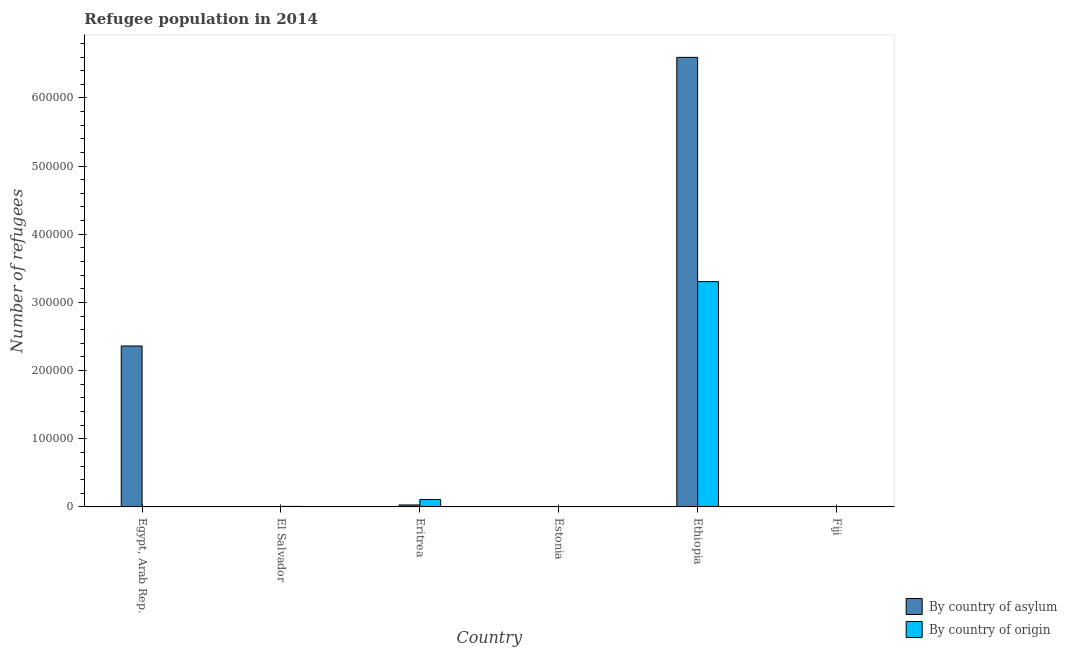How many groups of bars are there?
Your answer should be very brief. 6. Are the number of bars per tick equal to the number of legend labels?
Your answer should be very brief. Yes. Are the number of bars on each tick of the X-axis equal?
Provide a succinct answer. Yes. What is the label of the 3rd group of bars from the left?
Make the answer very short. Eritrea. In how many cases, is the number of bars for a given country not equal to the number of legend labels?
Offer a very short reply. 0. What is the number of refugees by country of origin in Fiji?
Make the answer very short. 339. Across all countries, what is the maximum number of refugees by country of origin?
Your answer should be very brief. 3.31e+05. Across all countries, what is the minimum number of refugees by country of asylum?
Make the answer very short. 13. In which country was the number of refugees by country of origin maximum?
Make the answer very short. Ethiopia. In which country was the number of refugees by country of origin minimum?
Provide a succinct answer. Estonia. What is the total number of refugees by country of asylum in the graph?
Provide a succinct answer. 8.99e+05. What is the difference between the number of refugees by country of asylum in Egypt, Arab Rep. and that in Fiji?
Make the answer very short. 2.36e+05. What is the difference between the number of refugees by country of origin in Fiji and the number of refugees by country of asylum in Estonia?
Provide a succinct answer. 249. What is the average number of refugees by country of asylum per country?
Your response must be concise. 1.50e+05. What is the difference between the number of refugees by country of asylum and number of refugees by country of origin in El Salvador?
Your response must be concise. -770. In how many countries, is the number of refugees by country of asylum greater than 660000 ?
Give a very brief answer. 0. What is the ratio of the number of refugees by country of origin in Egypt, Arab Rep. to that in Eritrea?
Offer a terse response. 0.03. What is the difference between the highest and the second highest number of refugees by country of origin?
Provide a succinct answer. 3.20e+05. What is the difference between the highest and the lowest number of refugees by country of asylum?
Make the answer very short. 6.60e+05. Is the sum of the number of refugees by country of asylum in Ethiopia and Fiji greater than the maximum number of refugees by country of origin across all countries?
Your answer should be very brief. Yes. What does the 1st bar from the left in Fiji represents?
Ensure brevity in your answer.  By country of asylum. What does the 1st bar from the right in El Salvador represents?
Give a very brief answer. By country of origin. How many bars are there?
Provide a succinct answer. 12. Are all the bars in the graph horizontal?
Keep it short and to the point. No. How many countries are there in the graph?
Make the answer very short. 6. Are the values on the major ticks of Y-axis written in scientific E-notation?
Offer a terse response. No. Does the graph contain grids?
Provide a short and direct response. No. How many legend labels are there?
Make the answer very short. 2. How are the legend labels stacked?
Give a very brief answer. Vertical. What is the title of the graph?
Offer a terse response. Refugee population in 2014. What is the label or title of the X-axis?
Offer a very short reply. Country. What is the label or title of the Y-axis?
Your answer should be compact. Number of refugees. What is the Number of refugees of By country of asylum in Egypt, Arab Rep.?
Keep it short and to the point. 2.36e+05. What is the Number of refugees of By country of origin in Egypt, Arab Rep.?
Your answer should be compact. 349. What is the Number of refugees in By country of asylum in El Salvador?
Your response must be concise. 35. What is the Number of refugees in By country of origin in El Salvador?
Make the answer very short. 805. What is the Number of refugees of By country of asylum in Eritrea?
Offer a very short reply. 2898. What is the Number of refugees of By country of origin in Eritrea?
Provide a short and direct response. 1.10e+04. What is the Number of refugees in By country of origin in Estonia?
Provide a succinct answer. 174. What is the Number of refugees of By country of asylum in Ethiopia?
Ensure brevity in your answer.  6.60e+05. What is the Number of refugees of By country of origin in Ethiopia?
Your answer should be very brief. 3.31e+05. What is the Number of refugees of By country of asylum in Fiji?
Offer a terse response. 13. What is the Number of refugees of By country of origin in Fiji?
Keep it short and to the point. 339. Across all countries, what is the maximum Number of refugees of By country of asylum?
Your response must be concise. 6.60e+05. Across all countries, what is the maximum Number of refugees in By country of origin?
Your answer should be compact. 3.31e+05. Across all countries, what is the minimum Number of refugees of By country of asylum?
Make the answer very short. 13. Across all countries, what is the minimum Number of refugees of By country of origin?
Give a very brief answer. 174. What is the total Number of refugees of By country of asylum in the graph?
Provide a succinct answer. 8.99e+05. What is the total Number of refugees of By country of origin in the graph?
Your answer should be very brief. 3.43e+05. What is the difference between the Number of refugees in By country of asylum in Egypt, Arab Rep. and that in El Salvador?
Your answer should be compact. 2.36e+05. What is the difference between the Number of refugees in By country of origin in Egypt, Arab Rep. and that in El Salvador?
Keep it short and to the point. -456. What is the difference between the Number of refugees in By country of asylum in Egypt, Arab Rep. and that in Eritrea?
Make the answer very short. 2.33e+05. What is the difference between the Number of refugees in By country of origin in Egypt, Arab Rep. and that in Eritrea?
Offer a very short reply. -1.06e+04. What is the difference between the Number of refugees in By country of asylum in Egypt, Arab Rep. and that in Estonia?
Your response must be concise. 2.36e+05. What is the difference between the Number of refugees of By country of origin in Egypt, Arab Rep. and that in Estonia?
Keep it short and to the point. 175. What is the difference between the Number of refugees of By country of asylum in Egypt, Arab Rep. and that in Ethiopia?
Offer a very short reply. -4.23e+05. What is the difference between the Number of refugees in By country of origin in Egypt, Arab Rep. and that in Ethiopia?
Your answer should be very brief. -3.30e+05. What is the difference between the Number of refugees in By country of asylum in Egypt, Arab Rep. and that in Fiji?
Ensure brevity in your answer.  2.36e+05. What is the difference between the Number of refugees in By country of origin in Egypt, Arab Rep. and that in Fiji?
Keep it short and to the point. 10. What is the difference between the Number of refugees in By country of asylum in El Salvador and that in Eritrea?
Your answer should be very brief. -2863. What is the difference between the Number of refugees of By country of origin in El Salvador and that in Eritrea?
Ensure brevity in your answer.  -1.02e+04. What is the difference between the Number of refugees in By country of asylum in El Salvador and that in Estonia?
Keep it short and to the point. -55. What is the difference between the Number of refugees in By country of origin in El Salvador and that in Estonia?
Offer a very short reply. 631. What is the difference between the Number of refugees of By country of asylum in El Salvador and that in Ethiopia?
Provide a succinct answer. -6.59e+05. What is the difference between the Number of refugees of By country of origin in El Salvador and that in Ethiopia?
Your answer should be very brief. -3.30e+05. What is the difference between the Number of refugees of By country of origin in El Salvador and that in Fiji?
Your answer should be compact. 466. What is the difference between the Number of refugees of By country of asylum in Eritrea and that in Estonia?
Your answer should be very brief. 2808. What is the difference between the Number of refugees in By country of origin in Eritrea and that in Estonia?
Ensure brevity in your answer.  1.08e+04. What is the difference between the Number of refugees in By country of asylum in Eritrea and that in Ethiopia?
Your response must be concise. -6.57e+05. What is the difference between the Number of refugees of By country of origin in Eritrea and that in Ethiopia?
Offer a very short reply. -3.20e+05. What is the difference between the Number of refugees of By country of asylum in Eritrea and that in Fiji?
Provide a succinct answer. 2885. What is the difference between the Number of refugees of By country of origin in Eritrea and that in Fiji?
Give a very brief answer. 1.06e+04. What is the difference between the Number of refugees of By country of asylum in Estonia and that in Ethiopia?
Make the answer very short. -6.59e+05. What is the difference between the Number of refugees of By country of origin in Estonia and that in Ethiopia?
Provide a succinct answer. -3.30e+05. What is the difference between the Number of refugees in By country of asylum in Estonia and that in Fiji?
Make the answer very short. 77. What is the difference between the Number of refugees of By country of origin in Estonia and that in Fiji?
Provide a succinct answer. -165. What is the difference between the Number of refugees of By country of asylum in Ethiopia and that in Fiji?
Offer a very short reply. 6.60e+05. What is the difference between the Number of refugees in By country of origin in Ethiopia and that in Fiji?
Provide a succinct answer. 3.30e+05. What is the difference between the Number of refugees of By country of asylum in Egypt, Arab Rep. and the Number of refugees of By country of origin in El Salvador?
Make the answer very short. 2.35e+05. What is the difference between the Number of refugees of By country of asylum in Egypt, Arab Rep. and the Number of refugees of By country of origin in Eritrea?
Make the answer very short. 2.25e+05. What is the difference between the Number of refugees of By country of asylum in Egypt, Arab Rep. and the Number of refugees of By country of origin in Estonia?
Provide a succinct answer. 2.36e+05. What is the difference between the Number of refugees in By country of asylum in Egypt, Arab Rep. and the Number of refugees in By country of origin in Ethiopia?
Ensure brevity in your answer.  -9.44e+04. What is the difference between the Number of refugees of By country of asylum in Egypt, Arab Rep. and the Number of refugees of By country of origin in Fiji?
Give a very brief answer. 2.36e+05. What is the difference between the Number of refugees in By country of asylum in El Salvador and the Number of refugees in By country of origin in Eritrea?
Provide a short and direct response. -1.09e+04. What is the difference between the Number of refugees of By country of asylum in El Salvador and the Number of refugees of By country of origin in Estonia?
Give a very brief answer. -139. What is the difference between the Number of refugees of By country of asylum in El Salvador and the Number of refugees of By country of origin in Ethiopia?
Provide a short and direct response. -3.30e+05. What is the difference between the Number of refugees of By country of asylum in El Salvador and the Number of refugees of By country of origin in Fiji?
Offer a very short reply. -304. What is the difference between the Number of refugees of By country of asylum in Eritrea and the Number of refugees of By country of origin in Estonia?
Keep it short and to the point. 2724. What is the difference between the Number of refugees in By country of asylum in Eritrea and the Number of refugees in By country of origin in Ethiopia?
Your response must be concise. -3.28e+05. What is the difference between the Number of refugees in By country of asylum in Eritrea and the Number of refugees in By country of origin in Fiji?
Make the answer very short. 2559. What is the difference between the Number of refugees in By country of asylum in Estonia and the Number of refugees in By country of origin in Ethiopia?
Keep it short and to the point. -3.30e+05. What is the difference between the Number of refugees in By country of asylum in Estonia and the Number of refugees in By country of origin in Fiji?
Offer a very short reply. -249. What is the difference between the Number of refugees of By country of asylum in Ethiopia and the Number of refugees of By country of origin in Fiji?
Ensure brevity in your answer.  6.59e+05. What is the average Number of refugees in By country of asylum per country?
Keep it short and to the point. 1.50e+05. What is the average Number of refugees of By country of origin per country?
Ensure brevity in your answer.  5.72e+04. What is the difference between the Number of refugees of By country of asylum and Number of refugees of By country of origin in Egypt, Arab Rep.?
Keep it short and to the point. 2.36e+05. What is the difference between the Number of refugees in By country of asylum and Number of refugees in By country of origin in El Salvador?
Keep it short and to the point. -770. What is the difference between the Number of refugees in By country of asylum and Number of refugees in By country of origin in Eritrea?
Give a very brief answer. -8067. What is the difference between the Number of refugees in By country of asylum and Number of refugees in By country of origin in Estonia?
Make the answer very short. -84. What is the difference between the Number of refugees in By country of asylum and Number of refugees in By country of origin in Ethiopia?
Make the answer very short. 3.29e+05. What is the difference between the Number of refugees of By country of asylum and Number of refugees of By country of origin in Fiji?
Provide a short and direct response. -326. What is the ratio of the Number of refugees of By country of asylum in Egypt, Arab Rep. to that in El Salvador?
Provide a succinct answer. 6745.43. What is the ratio of the Number of refugees of By country of origin in Egypt, Arab Rep. to that in El Salvador?
Give a very brief answer. 0.43. What is the ratio of the Number of refugees in By country of asylum in Egypt, Arab Rep. to that in Eritrea?
Keep it short and to the point. 81.47. What is the ratio of the Number of refugees of By country of origin in Egypt, Arab Rep. to that in Eritrea?
Provide a short and direct response. 0.03. What is the ratio of the Number of refugees of By country of asylum in Egypt, Arab Rep. to that in Estonia?
Offer a very short reply. 2623.22. What is the ratio of the Number of refugees in By country of origin in Egypt, Arab Rep. to that in Estonia?
Ensure brevity in your answer.  2.01. What is the ratio of the Number of refugees in By country of asylum in Egypt, Arab Rep. to that in Ethiopia?
Keep it short and to the point. 0.36. What is the ratio of the Number of refugees of By country of origin in Egypt, Arab Rep. to that in Ethiopia?
Your answer should be very brief. 0. What is the ratio of the Number of refugees of By country of asylum in Egypt, Arab Rep. to that in Fiji?
Offer a very short reply. 1.82e+04. What is the ratio of the Number of refugees in By country of origin in Egypt, Arab Rep. to that in Fiji?
Offer a very short reply. 1.03. What is the ratio of the Number of refugees in By country of asylum in El Salvador to that in Eritrea?
Keep it short and to the point. 0.01. What is the ratio of the Number of refugees in By country of origin in El Salvador to that in Eritrea?
Your answer should be compact. 0.07. What is the ratio of the Number of refugees in By country of asylum in El Salvador to that in Estonia?
Provide a short and direct response. 0.39. What is the ratio of the Number of refugees in By country of origin in El Salvador to that in Estonia?
Make the answer very short. 4.63. What is the ratio of the Number of refugees in By country of asylum in El Salvador to that in Ethiopia?
Your answer should be compact. 0. What is the ratio of the Number of refugees in By country of origin in El Salvador to that in Ethiopia?
Make the answer very short. 0. What is the ratio of the Number of refugees in By country of asylum in El Salvador to that in Fiji?
Your answer should be very brief. 2.69. What is the ratio of the Number of refugees in By country of origin in El Salvador to that in Fiji?
Your answer should be very brief. 2.37. What is the ratio of the Number of refugees of By country of asylum in Eritrea to that in Estonia?
Your answer should be very brief. 32.2. What is the ratio of the Number of refugees of By country of origin in Eritrea to that in Estonia?
Provide a succinct answer. 63.02. What is the ratio of the Number of refugees in By country of asylum in Eritrea to that in Ethiopia?
Provide a short and direct response. 0. What is the ratio of the Number of refugees in By country of origin in Eritrea to that in Ethiopia?
Ensure brevity in your answer.  0.03. What is the ratio of the Number of refugees in By country of asylum in Eritrea to that in Fiji?
Ensure brevity in your answer.  222.92. What is the ratio of the Number of refugees in By country of origin in Eritrea to that in Fiji?
Provide a short and direct response. 32.35. What is the ratio of the Number of refugees of By country of asylum in Estonia to that in Ethiopia?
Ensure brevity in your answer.  0. What is the ratio of the Number of refugees in By country of asylum in Estonia to that in Fiji?
Provide a succinct answer. 6.92. What is the ratio of the Number of refugees of By country of origin in Estonia to that in Fiji?
Your answer should be compact. 0.51. What is the ratio of the Number of refugees in By country of asylum in Ethiopia to that in Fiji?
Keep it short and to the point. 5.07e+04. What is the ratio of the Number of refugees in By country of origin in Ethiopia to that in Fiji?
Your answer should be very brief. 975. What is the difference between the highest and the second highest Number of refugees in By country of asylum?
Make the answer very short. 4.23e+05. What is the difference between the highest and the second highest Number of refugees in By country of origin?
Offer a very short reply. 3.20e+05. What is the difference between the highest and the lowest Number of refugees of By country of asylum?
Offer a very short reply. 6.60e+05. What is the difference between the highest and the lowest Number of refugees of By country of origin?
Provide a succinct answer. 3.30e+05. 